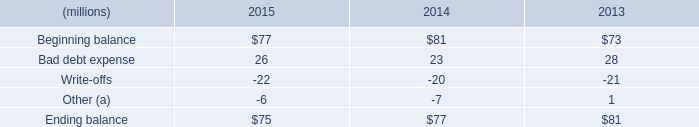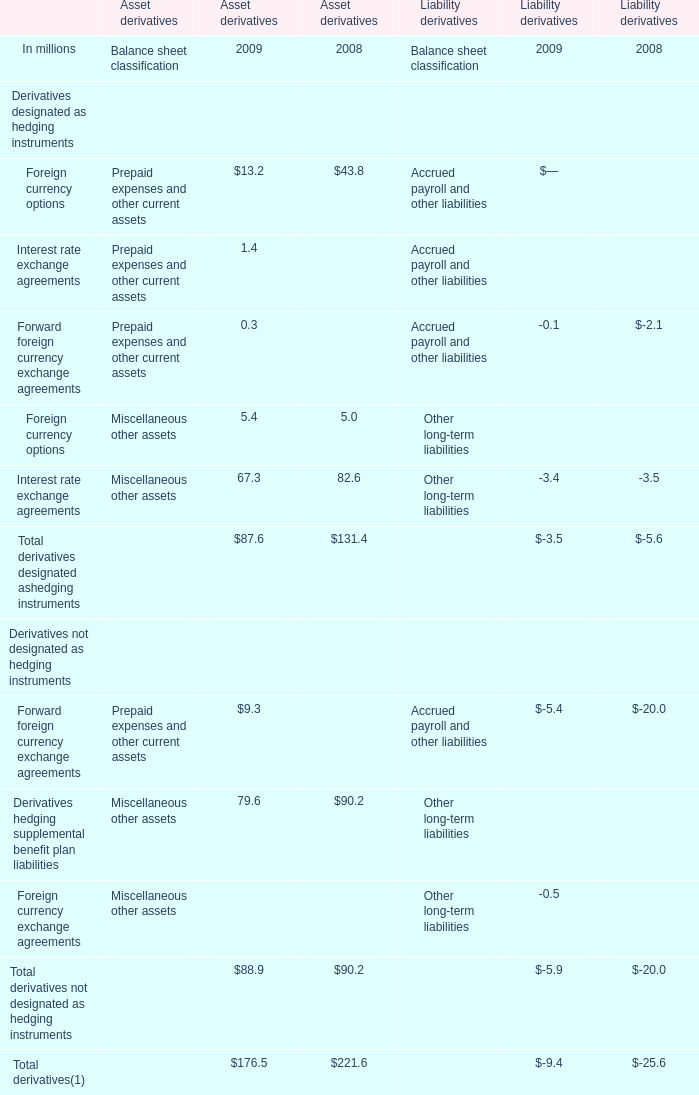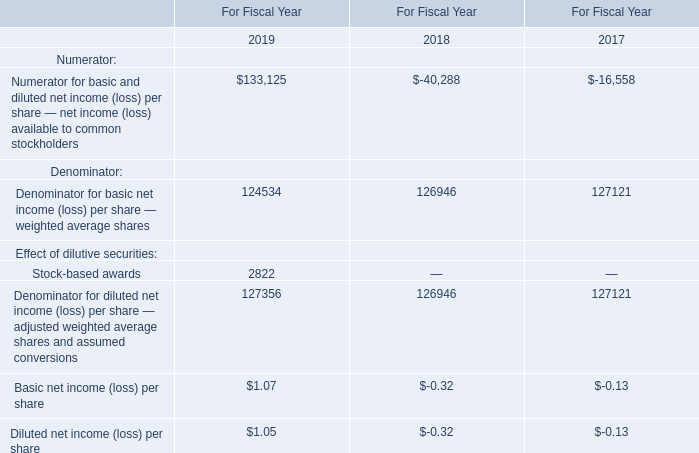What's the total amount of the elements in the years where Foreign currency options for Asset derivatives is greater than 40? (in million) 
Computations: (221.6 - 25.6)
Answer: 196.0. 